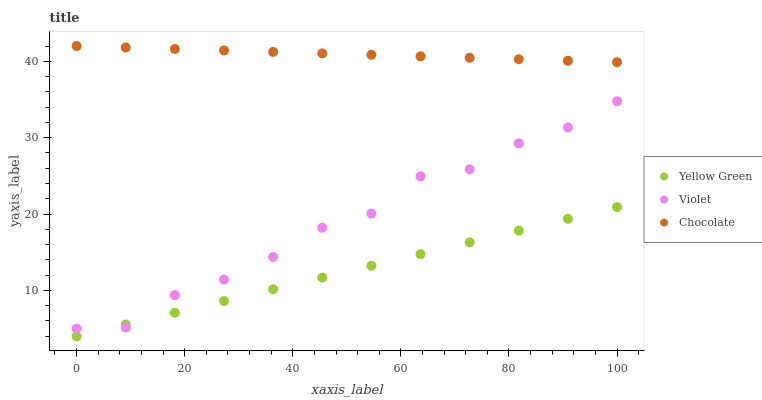Does Yellow Green have the minimum area under the curve?
Answer yes or no. Yes. Does Chocolate have the maximum area under the curve?
Answer yes or no. Yes. Does Violet have the minimum area under the curve?
Answer yes or no. No. Does Violet have the maximum area under the curve?
Answer yes or no. No. Is Yellow Green the smoothest?
Answer yes or no. Yes. Is Violet the roughest?
Answer yes or no. Yes. Is Violet the smoothest?
Answer yes or no. No. Is Yellow Green the roughest?
Answer yes or no. No. Does Yellow Green have the lowest value?
Answer yes or no. Yes. Does Violet have the lowest value?
Answer yes or no. No. Does Chocolate have the highest value?
Answer yes or no. Yes. Does Violet have the highest value?
Answer yes or no. No. Is Violet less than Chocolate?
Answer yes or no. Yes. Is Chocolate greater than Yellow Green?
Answer yes or no. Yes. Does Yellow Green intersect Violet?
Answer yes or no. Yes. Is Yellow Green less than Violet?
Answer yes or no. No. Is Yellow Green greater than Violet?
Answer yes or no. No. Does Violet intersect Chocolate?
Answer yes or no. No. 